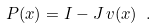<formula> <loc_0><loc_0><loc_500><loc_500>P ( x ) = I - J \, v ( x ) \ .</formula> 